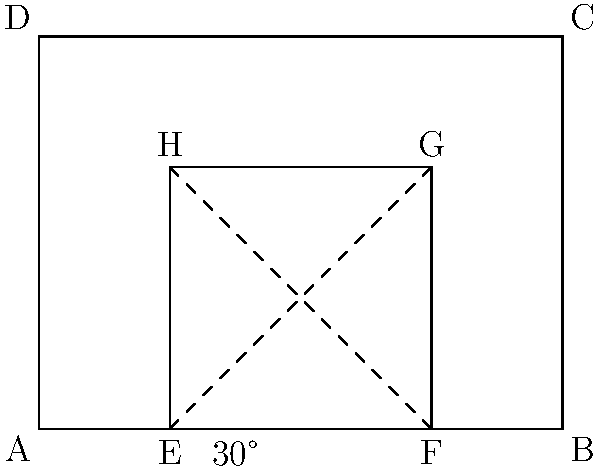You're designing a new greenhouse for your organic farm to cultivate botanical ingredients for natural hair care products. The greenhouse has a rectangular base (ABCD) with dimensions 8m by 6m. Inside, you want to create a smaller growing area (EFGH) with a 2m walkway around it. If the roof peak angle at the center is 30°, what is the height of the greenhouse at its highest point? Let's approach this step-by-step:

1) First, we need to find the width of the inner growing area (EFGH):
   Width of EFGH = Total width - (2 × walkway width)
   $$ 8m - (2 × 2m) = 4m $$

2) The roof peak will be at the center of this 4m span.

3) We can split this into two right triangles. The base of each triangle is half of the 4m span:
   $$ \frac{4m}{2} = 2m $$

4) We now have a right triangle where we know:
   - The angle at the base is 30°
   - The adjacent side (half of the inner width) is 2m

5) We can use the tangent function to find the height:
   $$ \tan(30°) = \frac{\text{opposite}}{\text{adjacent}} = \frac{height}{2m} $$

6) Rearranging this equation:
   $$ height = 2m × \tan(30°) $$

7) We know that $\tan(30°) = \frac{1}{\sqrt{3}}$, so:
   $$ height = 2m × \frac{1}{\sqrt{3}} = \frac{2m}{\sqrt{3}} $$

8) To simplify this:
   $$ \frac{2m}{\sqrt{3}} = \frac{2m}{\sqrt{3}} × \frac{\sqrt{3}}{\sqrt{3}} = \frac{2m\sqrt{3}}{3} ≈ 1.15m $$

9) This is the height from the top of the inner growing area. To get the total height, we need to add the height of the inner growing area:
   Total height = Height of inner area + Roof height
   $$ 4m + \frac{2m\sqrt{3}}{3} ≈ 4m + 1.15m = 5.15m $$
Answer: $5.15m$ (or $4 + \frac{2\sqrt{3}}{3}m$ exactly) 